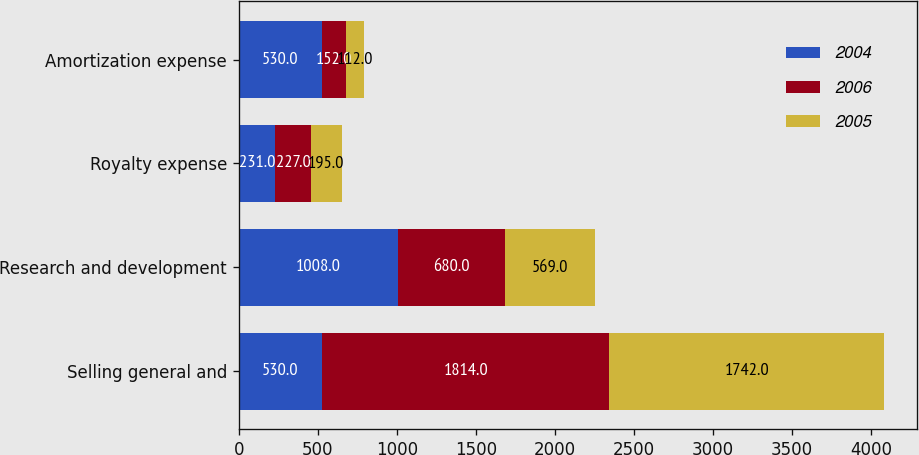<chart> <loc_0><loc_0><loc_500><loc_500><stacked_bar_chart><ecel><fcel>Selling general and<fcel>Research and development<fcel>Royalty expense<fcel>Amortization expense<nl><fcel>2004<fcel>530<fcel>1008<fcel>231<fcel>530<nl><fcel>2006<fcel>1814<fcel>680<fcel>227<fcel>152<nl><fcel>2005<fcel>1742<fcel>569<fcel>195<fcel>112<nl></chart> 